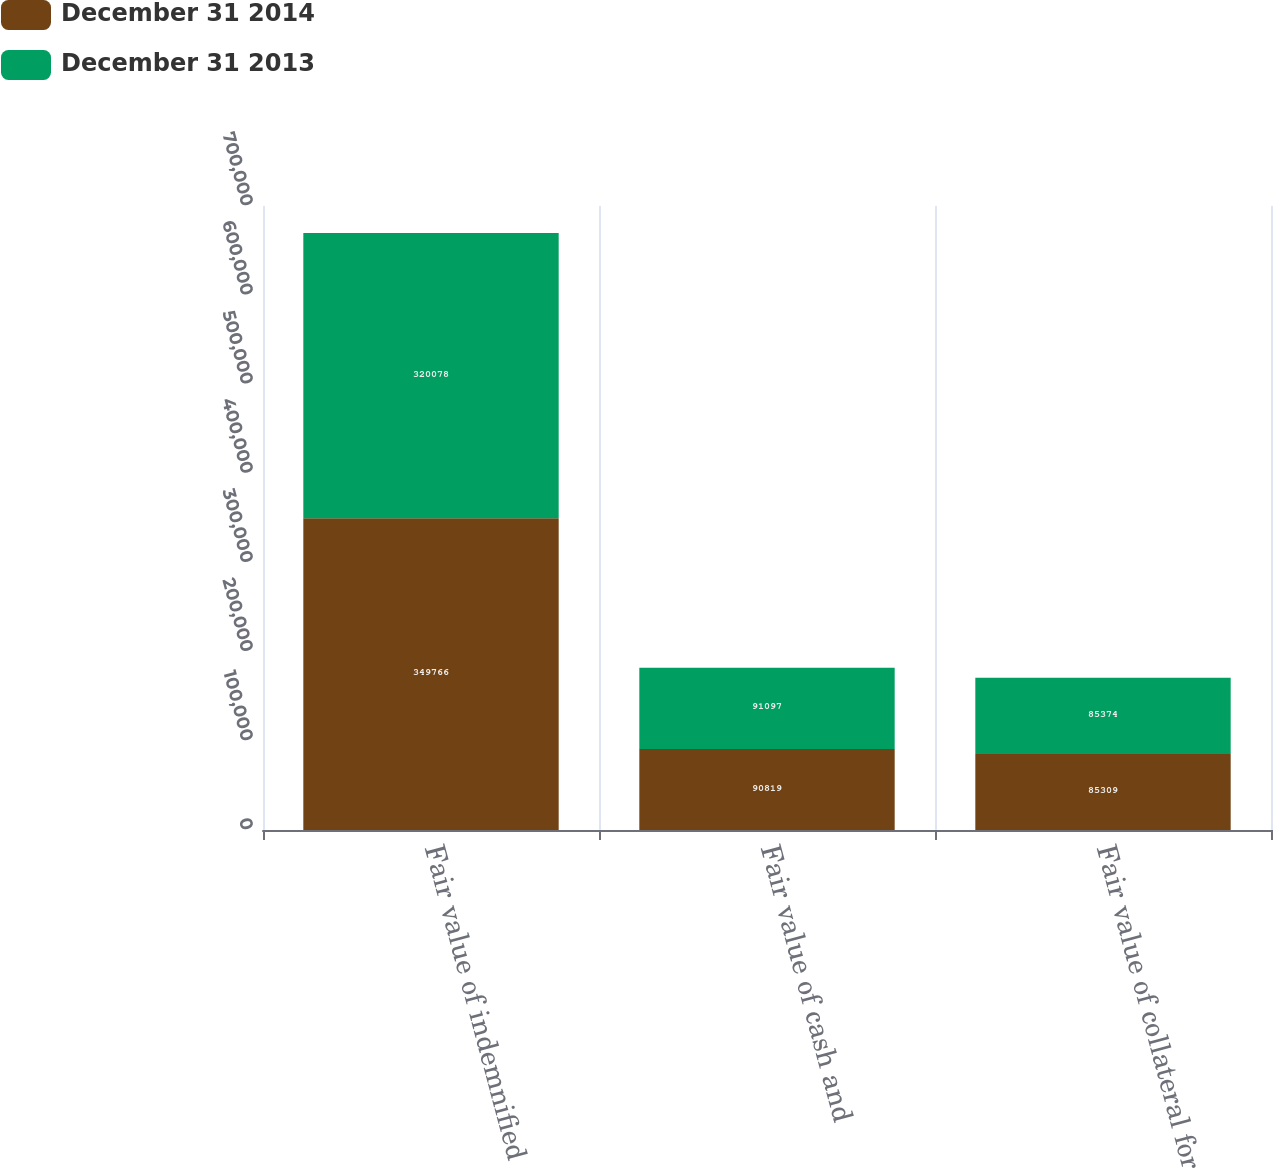<chart> <loc_0><loc_0><loc_500><loc_500><stacked_bar_chart><ecel><fcel>Fair value of indemnified<fcel>Fair value of cash and<fcel>Fair value of collateral for<nl><fcel>December 31 2014<fcel>349766<fcel>90819<fcel>85309<nl><fcel>December 31 2013<fcel>320078<fcel>91097<fcel>85374<nl></chart> 